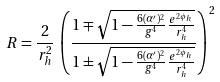Convert formula to latex. <formula><loc_0><loc_0><loc_500><loc_500>R = \frac { 2 } { r _ { h } ^ { 2 } } \, \left ( \frac { 1 \mp \sqrt { 1 - \frac { 6 ( \alpha ^ { \prime } ) ^ { 2 } } { g ^ { 4 } } \frac { e ^ { 2 \phi _ { h } } } { r _ { h } ^ { 4 } } } } { 1 \pm \sqrt { 1 - \frac { 6 ( \alpha ^ { \prime } ) ^ { 2 } } { g ^ { 4 } } \frac { e ^ { 2 \phi _ { h } } } { r _ { h } ^ { 4 } } } } \right ) ^ { 2 }</formula> 